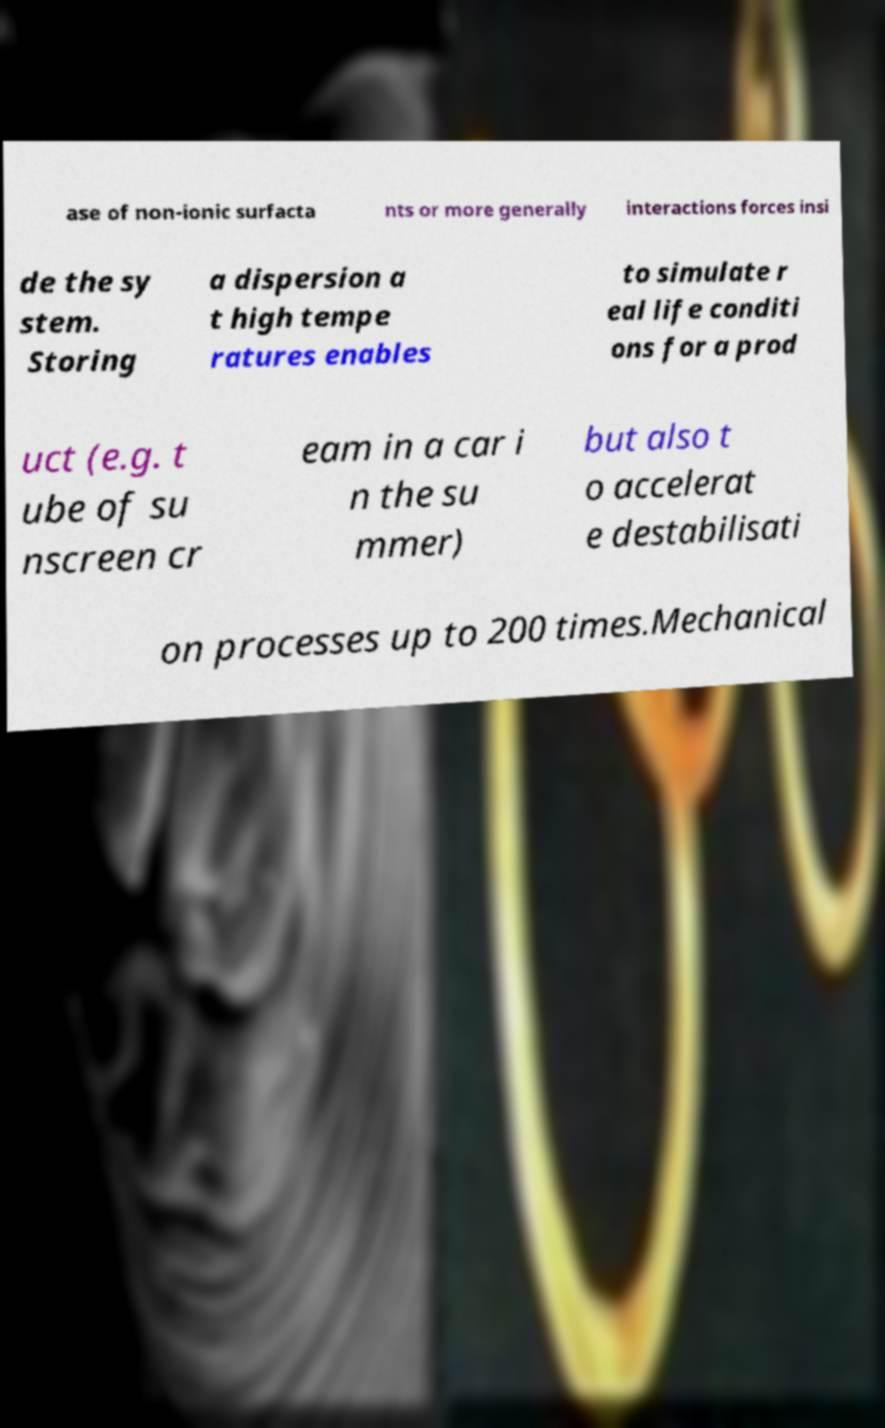I need the written content from this picture converted into text. Can you do that? ase of non-ionic surfacta nts or more generally interactions forces insi de the sy stem. Storing a dispersion a t high tempe ratures enables to simulate r eal life conditi ons for a prod uct (e.g. t ube of su nscreen cr eam in a car i n the su mmer) but also t o accelerat e destabilisati on processes up to 200 times.Mechanical 